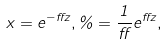Convert formula to latex. <formula><loc_0><loc_0><loc_500><loc_500>x = e ^ { - \alpha z } , \varrho = \frac { 1 } { \alpha } e ^ { \alpha z } ,</formula> 